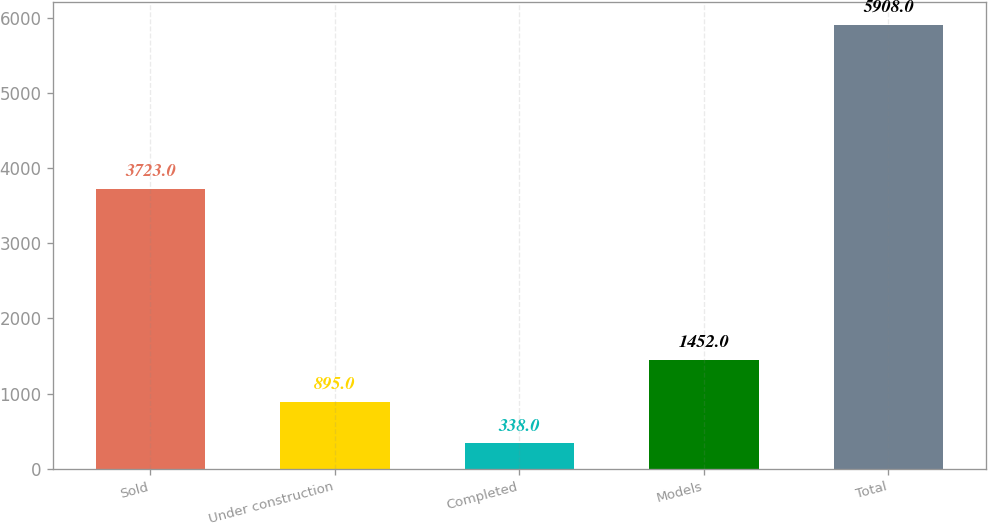Convert chart to OTSL. <chart><loc_0><loc_0><loc_500><loc_500><bar_chart><fcel>Sold<fcel>Under construction<fcel>Completed<fcel>Models<fcel>Total<nl><fcel>3723<fcel>895<fcel>338<fcel>1452<fcel>5908<nl></chart> 